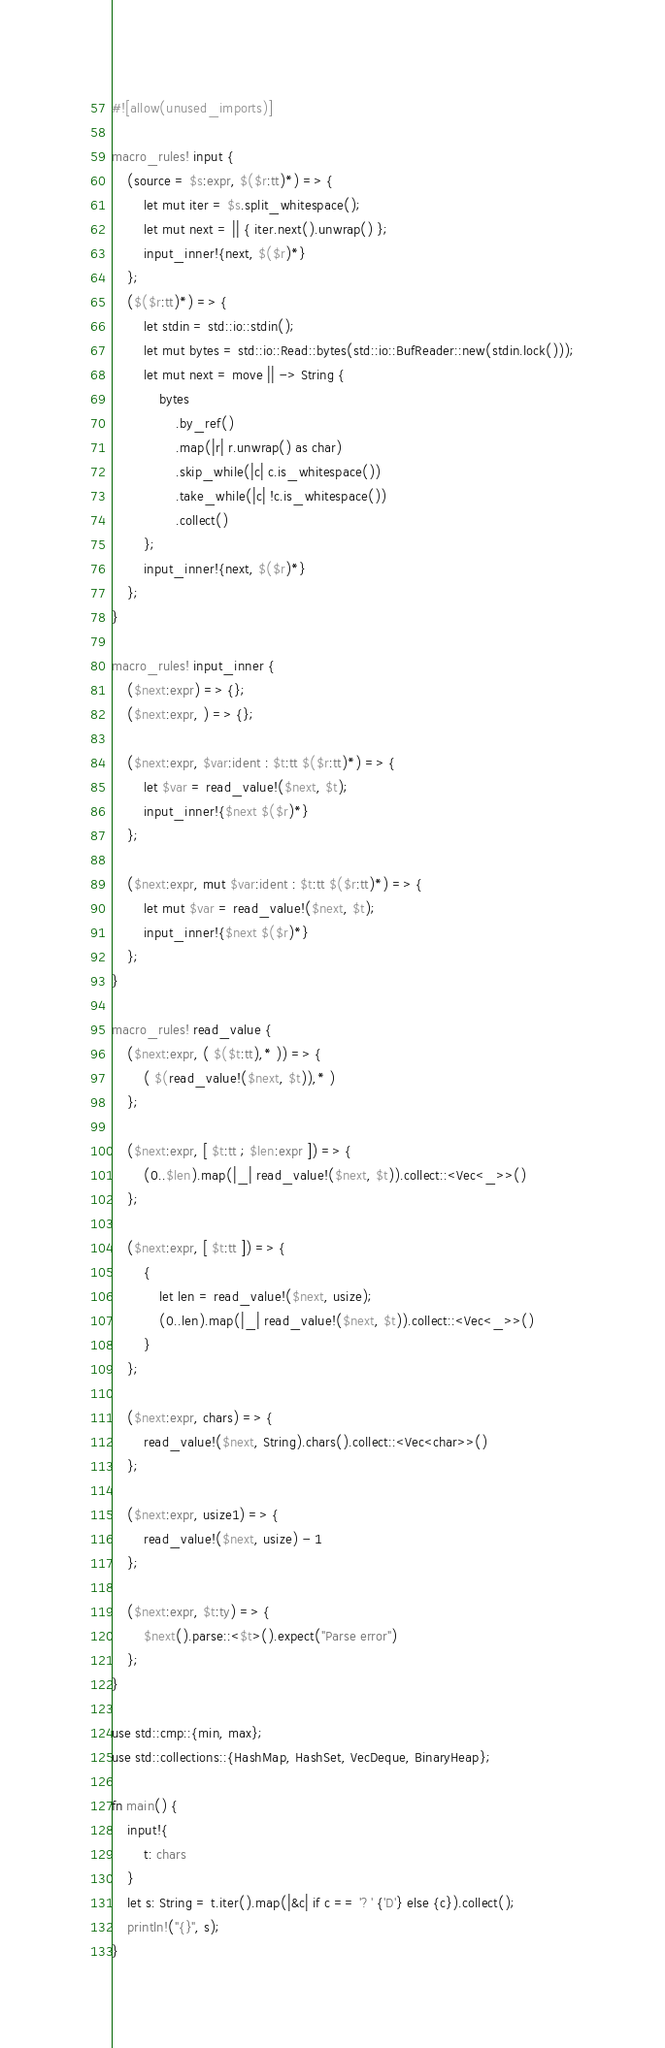<code> <loc_0><loc_0><loc_500><loc_500><_Rust_>#![allow(unused_imports)]

macro_rules! input {
    (source = $s:expr, $($r:tt)*) => {
        let mut iter = $s.split_whitespace();
        let mut next = || { iter.next().unwrap() };
        input_inner!{next, $($r)*}
    };
    ($($r:tt)*) => {
        let stdin = std::io::stdin();
        let mut bytes = std::io::Read::bytes(std::io::BufReader::new(stdin.lock()));
        let mut next = move || -> String {
            bytes
                .by_ref()
                .map(|r| r.unwrap() as char)
                .skip_while(|c| c.is_whitespace())
                .take_while(|c| !c.is_whitespace())
                .collect()
        };
        input_inner!{next, $($r)*}
    };
}

macro_rules! input_inner {
    ($next:expr) => {};
    ($next:expr, ) => {};

    ($next:expr, $var:ident : $t:tt $($r:tt)*) => {
        let $var = read_value!($next, $t);
        input_inner!{$next $($r)*}
    };

    ($next:expr, mut $var:ident : $t:tt $($r:tt)*) => {
        let mut $var = read_value!($next, $t);
        input_inner!{$next $($r)*}
    };
}

macro_rules! read_value {
    ($next:expr, ( $($t:tt),* )) => {
        ( $(read_value!($next, $t)),* )
    };

    ($next:expr, [ $t:tt ; $len:expr ]) => {
        (0..$len).map(|_| read_value!($next, $t)).collect::<Vec<_>>()
    };

    ($next:expr, [ $t:tt ]) => {
        {
            let len = read_value!($next, usize);
            (0..len).map(|_| read_value!($next, $t)).collect::<Vec<_>>()
        }
    };

    ($next:expr, chars) => {
        read_value!($next, String).chars().collect::<Vec<char>>()
    };

    ($next:expr, usize1) => {
        read_value!($next, usize) - 1
    };

    ($next:expr, $t:ty) => {
        $next().parse::<$t>().expect("Parse error")
    };
}

use std::cmp::{min, max};
use std::collections::{HashMap, HashSet, VecDeque, BinaryHeap};

fn main() {
    input!{
        t: chars
    }
    let s: String = t.iter().map(|&c| if c == '?' {'D'} else {c}).collect();
    println!("{}", s);
}
</code> 